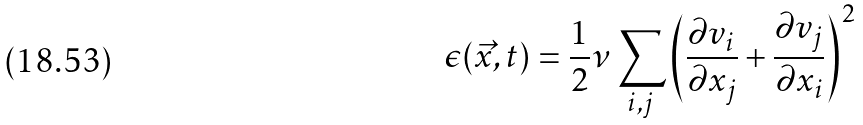<formula> <loc_0><loc_0><loc_500><loc_500>\epsilon ( \vec { x } , t ) = \frac { 1 } { 2 } \nu \sum _ { i , j } \left ( \frac { \partial v _ { i } } { \partial x _ { j } } + \frac { \partial v _ { j } } { \partial x _ { i } } \right ) ^ { 2 }</formula> 